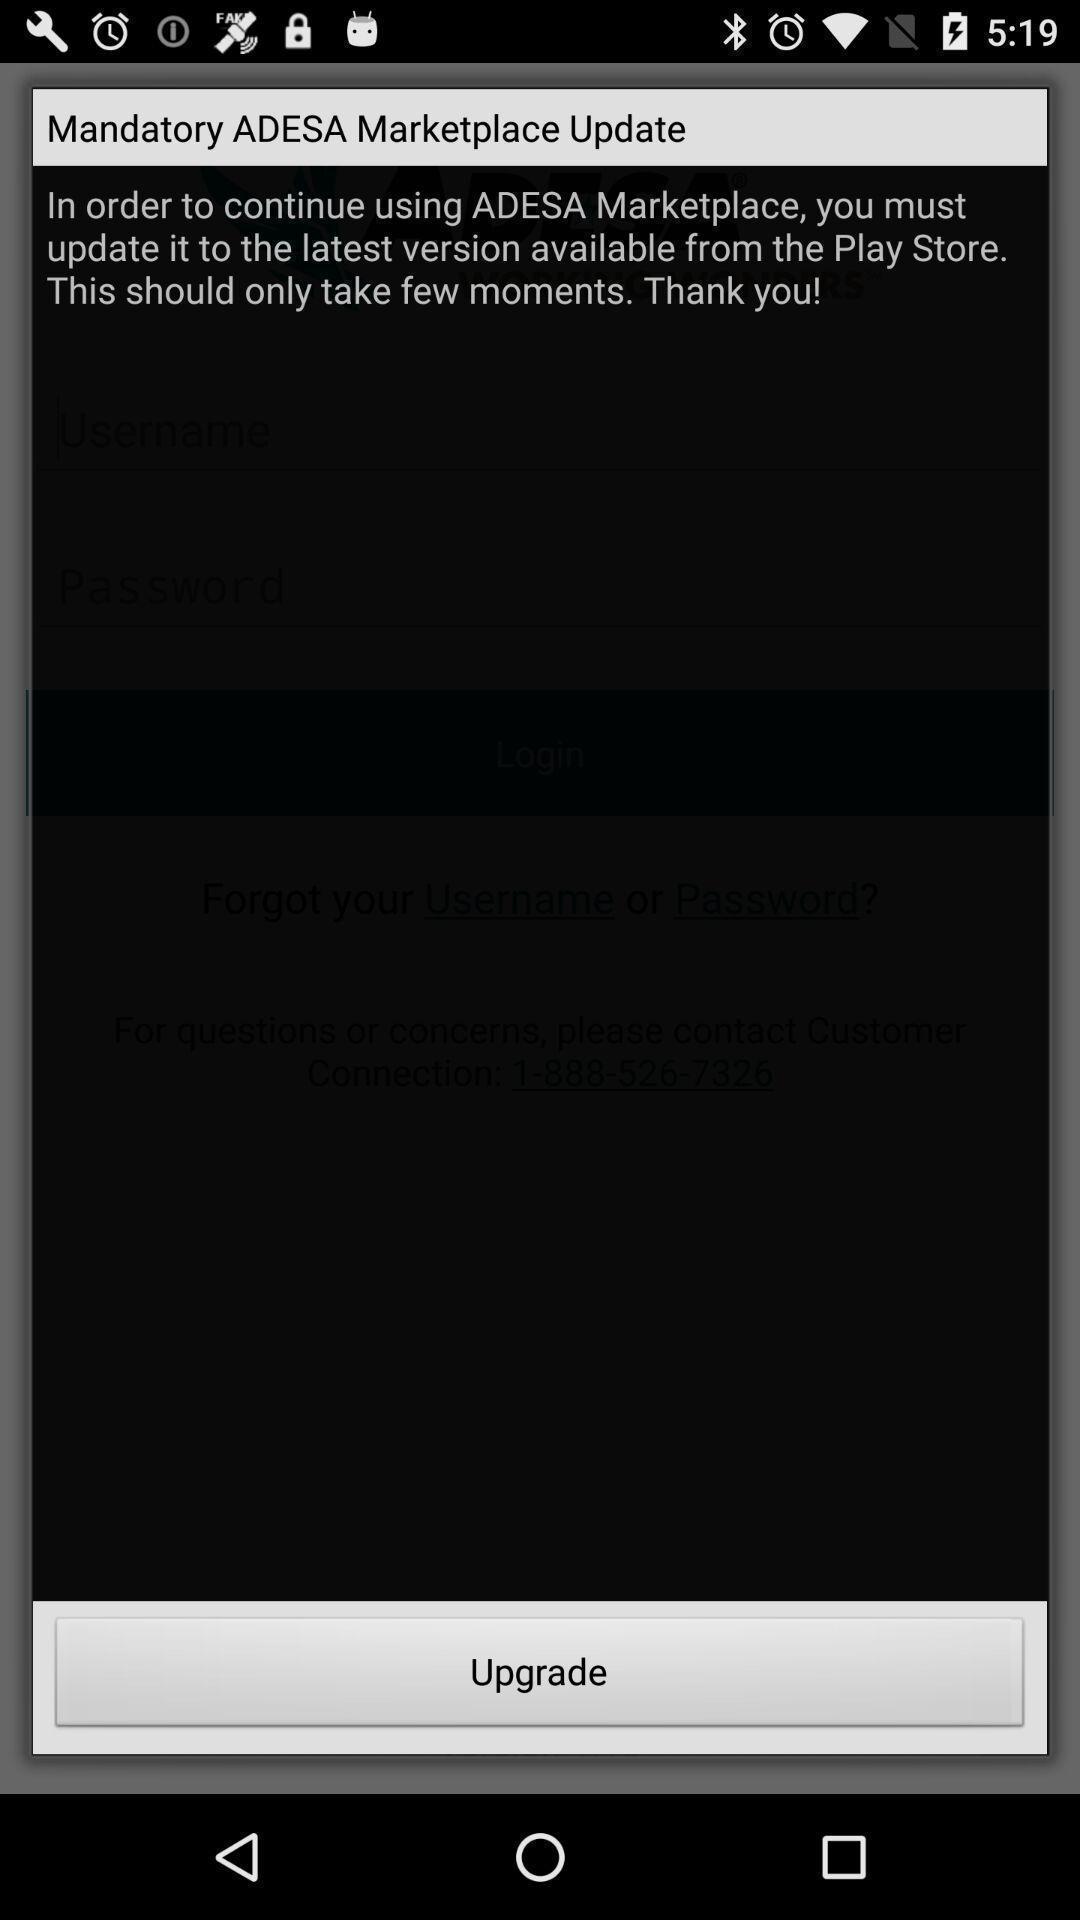Provide a detailed account of this screenshot. Page showing an update on a financial app. 